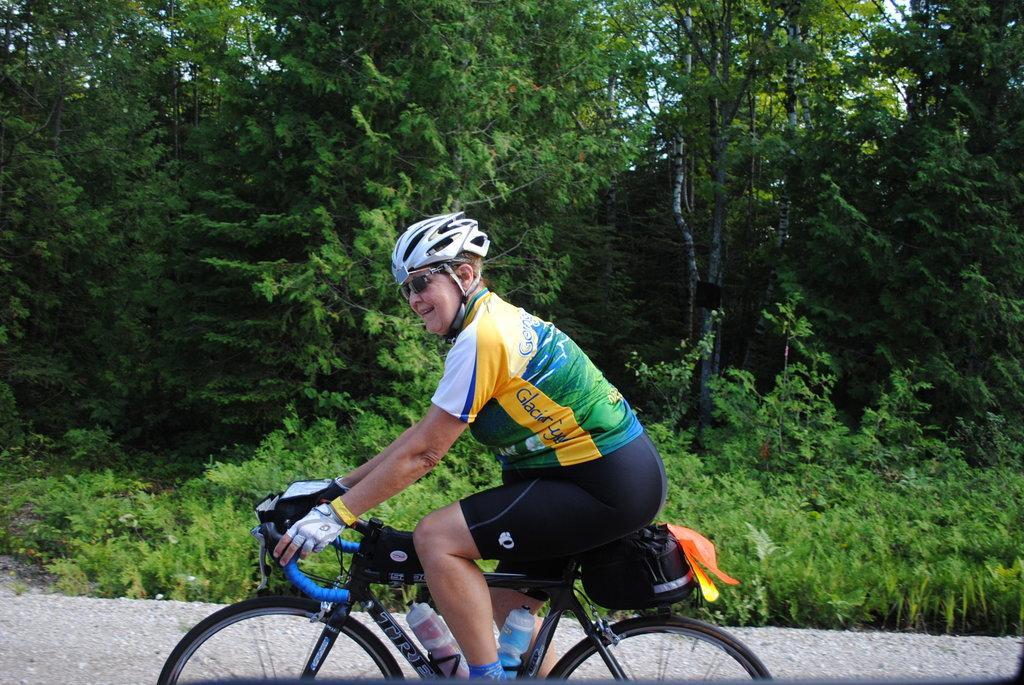Please provide a concise description of this image. In this image in the center there is a person riding a bicycle and smiling. In the background there are trees. 